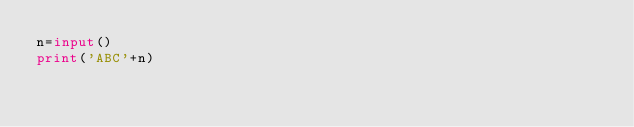<code> <loc_0><loc_0><loc_500><loc_500><_Python_>n=input()
print('ABC'+n)</code> 